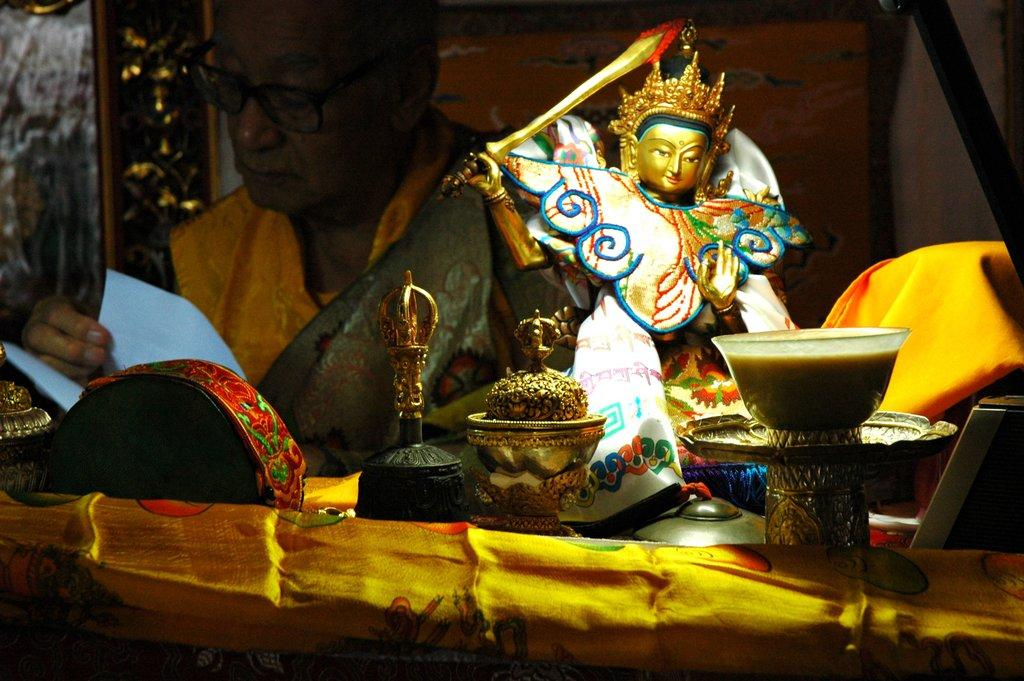What is the main object in the image? There is a statue in the image. What else can be seen in the image besides the statue? There are bowls, a man, and a table in the image. What is the man doing in the image? The man is sitting at a table and holding papers in his hand. What is on the table in the image? There is a cloth on the table in the image. What is the man wearing in the image? The man is wearing spectacles in the image. Where is the nearest mine to the location of the image? There is no information about a mine in the image or the surrounding area, so it cannot be determined. 